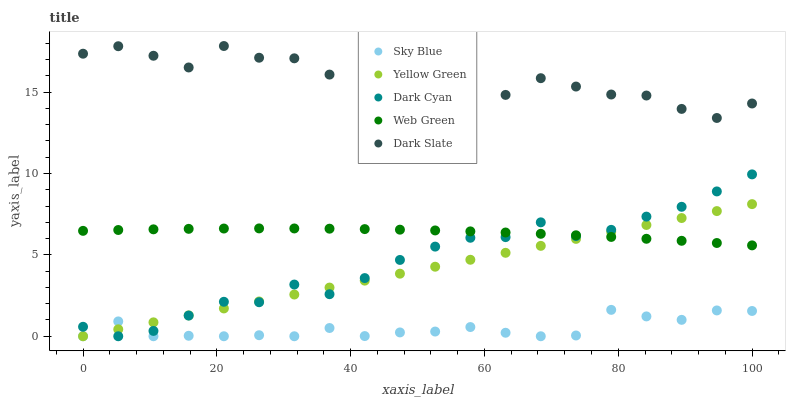Does Sky Blue have the minimum area under the curve?
Answer yes or no. Yes. Does Dark Slate have the maximum area under the curve?
Answer yes or no. Yes. Does Yellow Green have the minimum area under the curve?
Answer yes or no. No. Does Yellow Green have the maximum area under the curve?
Answer yes or no. No. Is Yellow Green the smoothest?
Answer yes or no. Yes. Is Dark Slate the roughest?
Answer yes or no. Yes. Is Sky Blue the smoothest?
Answer yes or no. No. Is Sky Blue the roughest?
Answer yes or no. No. Does Dark Cyan have the lowest value?
Answer yes or no. Yes. Does Web Green have the lowest value?
Answer yes or no. No. Does Dark Slate have the highest value?
Answer yes or no. Yes. Does Yellow Green have the highest value?
Answer yes or no. No. Is Yellow Green less than Dark Slate?
Answer yes or no. Yes. Is Dark Slate greater than Yellow Green?
Answer yes or no. Yes. Does Web Green intersect Yellow Green?
Answer yes or no. Yes. Is Web Green less than Yellow Green?
Answer yes or no. No. Is Web Green greater than Yellow Green?
Answer yes or no. No. Does Yellow Green intersect Dark Slate?
Answer yes or no. No. 